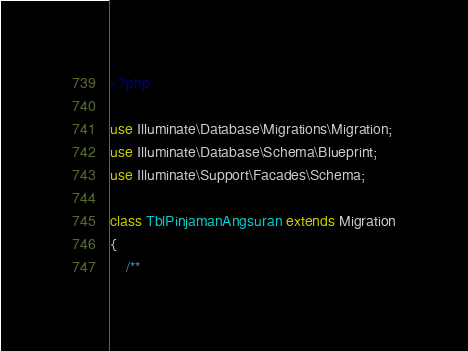Convert code to text. <code><loc_0><loc_0><loc_500><loc_500><_PHP_><?php

use Illuminate\Database\Migrations\Migration;
use Illuminate\Database\Schema\Blueprint;
use Illuminate\Support\Facades\Schema;

class TblPinjamanAngsuran extends Migration
{
    /**</code> 